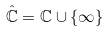<formula> <loc_0><loc_0><loc_500><loc_500>\mathbb { \hat { C } } = \mathbb { C } \cup \{ \infty \}</formula> 